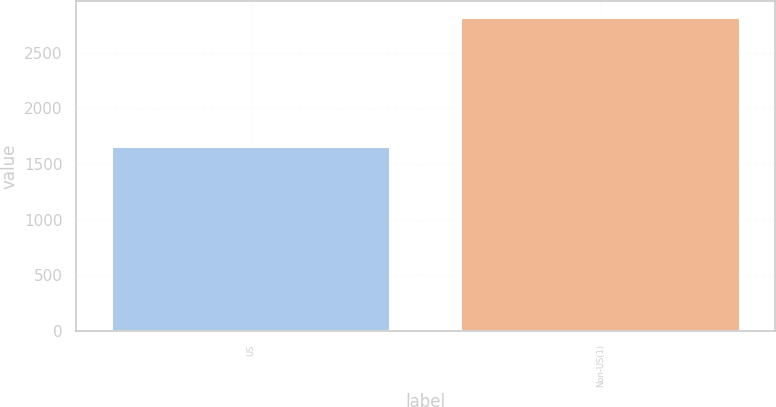<chart> <loc_0><loc_0><loc_500><loc_500><bar_chart><fcel>US<fcel>Non-US(1)<nl><fcel>1662<fcel>2820<nl></chart> 